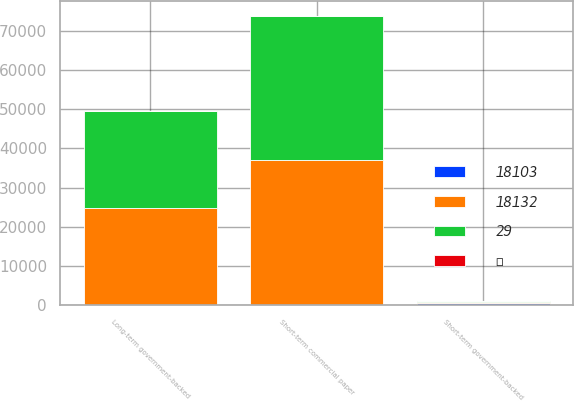Convert chart. <chart><loc_0><loc_0><loc_500><loc_500><stacked_bar_chart><ecel><fcel>Short-term government-backed<fcel>Short-term commercial paper<fcel>Long-term government-backed<nl><fcel>29<fcel>300.5<fcel>36936<fcel>24798<nl><fcel><fcel>3<fcel>2<fcel>1<nl><fcel>18103<fcel>538<fcel>63<fcel>12<nl><fcel>18132<fcel>300.5<fcel>36875<fcel>24787<nl></chart> 